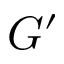<formula> <loc_0><loc_0><loc_500><loc_500>G ^ { \prime }</formula> 